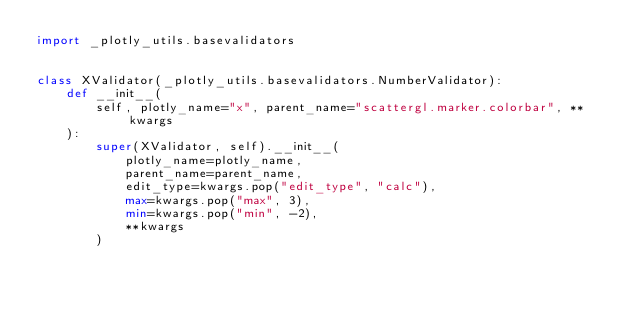<code> <loc_0><loc_0><loc_500><loc_500><_Python_>import _plotly_utils.basevalidators


class XValidator(_plotly_utils.basevalidators.NumberValidator):
    def __init__(
        self, plotly_name="x", parent_name="scattergl.marker.colorbar", **kwargs
    ):
        super(XValidator, self).__init__(
            plotly_name=plotly_name,
            parent_name=parent_name,
            edit_type=kwargs.pop("edit_type", "calc"),
            max=kwargs.pop("max", 3),
            min=kwargs.pop("min", -2),
            **kwargs
        )
</code> 